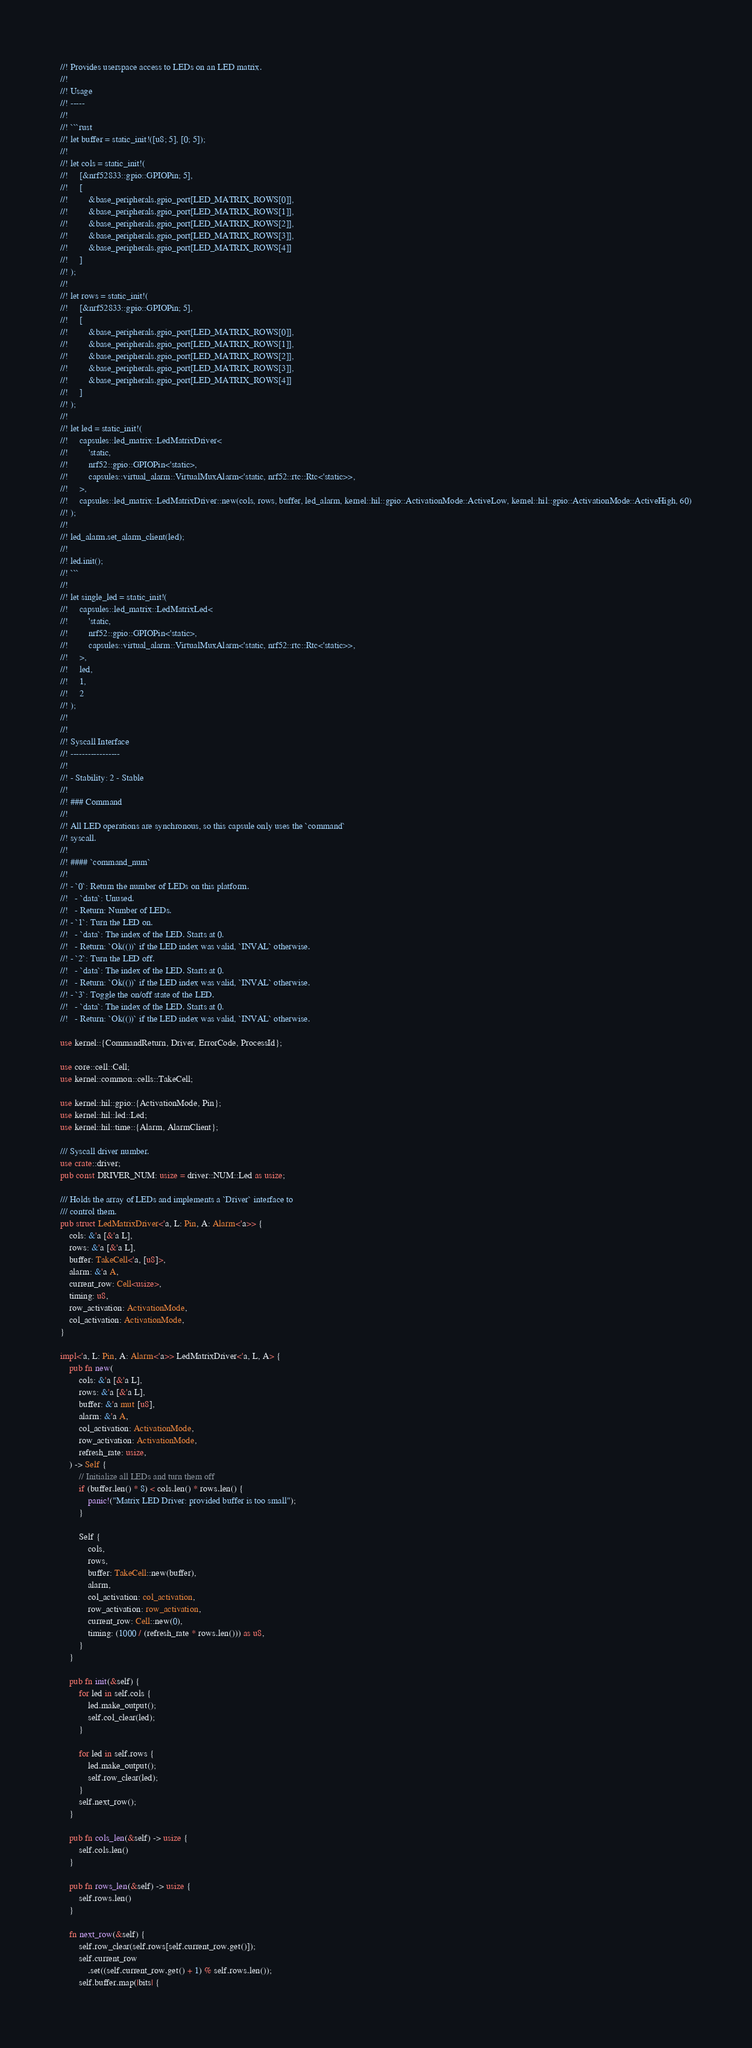<code> <loc_0><loc_0><loc_500><loc_500><_Rust_>//! Provides userspace access to LEDs on an LED matrix.
//!
//! Usage
//! -----
//!
//! ```rust
//! let buffer = static_init!([u8; 5], [0; 5]);
//!
//! let cols = static_init!(
//!     [&nrf52833::gpio::GPIOPin; 5],
//!     [
//!         &base_peripherals.gpio_port[LED_MATRIX_ROWS[0]],
//!         &base_peripherals.gpio_port[LED_MATRIX_ROWS[1]],
//!         &base_peripherals.gpio_port[LED_MATRIX_ROWS[2]],
//!         &base_peripherals.gpio_port[LED_MATRIX_ROWS[3]],
//!         &base_peripherals.gpio_port[LED_MATRIX_ROWS[4]]
//!     ]
//! );
//!
//! let rows = static_init!(
//!     [&nrf52833::gpio::GPIOPin; 5],
//!     [
//!         &base_peripherals.gpio_port[LED_MATRIX_ROWS[0]],
//!         &base_peripherals.gpio_port[LED_MATRIX_ROWS[1]],
//!         &base_peripherals.gpio_port[LED_MATRIX_ROWS[2]],
//!         &base_peripherals.gpio_port[LED_MATRIX_ROWS[3]],
//!         &base_peripherals.gpio_port[LED_MATRIX_ROWS[4]]
//!     ]
//! );
//!
//! let led = static_init!(
//!     capsules::led_matrix::LedMatrixDriver<
//!         'static,
//!         nrf52::gpio::GPIOPin<'static>,
//!         capsules::virtual_alarm::VirtualMuxAlarm<'static, nrf52::rtc::Rtc<'static>>,
//!     >,
//!     capsules::led_matrix::LedMatrixDriver::new(cols, rows, buffer, led_alarm, kernel::hil::gpio::ActivationMode::ActiveLow, kernel::hil::gpio::ActivationMode::ActiveHigh, 60)
//! );
//!
//! led_alarm.set_alarm_client(led);
//!
//! led.init();
//! ```
//!
//! let single_led = static_init!(
//!     capsules::led_matrix::LedMatrixLed<
//!         'static,
//!         nrf52::gpio::GPIOPin<'static>,
//!         capsules::virtual_alarm::VirtualMuxAlarm<'static, nrf52::rtc::Rtc<'static>>,
//!     >,
//!     led,
//!     1,
//!     2
//! );
//!
//!
//! Syscall Interface
//! -----------------
//!
//! - Stability: 2 - Stable
//!
//! ### Command
//!
//! All LED operations are synchronous, so this capsule only uses the `command`
//! syscall.
//!
//! #### `command_num`
//!
//! - `0`: Return the number of LEDs on this platform.
//!   - `data`: Unused.
//!   - Return: Number of LEDs.
//! - `1`: Turn the LED on.
//!   - `data`: The index of the LED. Starts at 0.
//!   - Return: `Ok(())` if the LED index was valid, `INVAL` otherwise.
//! - `2`: Turn the LED off.
//!   - `data`: The index of the LED. Starts at 0.
//!   - Return: `Ok(())` if the LED index was valid, `INVAL` otherwise.
//! - `3`: Toggle the on/off state of the LED.
//!   - `data`: The index of the LED. Starts at 0.
//!   - Return: `Ok(())` if the LED index was valid, `INVAL` otherwise.

use kernel::{CommandReturn, Driver, ErrorCode, ProcessId};

use core::cell::Cell;
use kernel::common::cells::TakeCell;

use kernel::hil::gpio::{ActivationMode, Pin};
use kernel::hil::led::Led;
use kernel::hil::time::{Alarm, AlarmClient};

/// Syscall driver number.
use crate::driver;
pub const DRIVER_NUM: usize = driver::NUM::Led as usize;

/// Holds the array of LEDs and implements a `Driver` interface to
/// control them.
pub struct LedMatrixDriver<'a, L: Pin, A: Alarm<'a>> {
    cols: &'a [&'a L],
    rows: &'a [&'a L],
    buffer: TakeCell<'a, [u8]>,
    alarm: &'a A,
    current_row: Cell<usize>,
    timing: u8,
    row_activation: ActivationMode,
    col_activation: ActivationMode,
}

impl<'a, L: Pin, A: Alarm<'a>> LedMatrixDriver<'a, L, A> {
    pub fn new(
        cols: &'a [&'a L],
        rows: &'a [&'a L],
        buffer: &'a mut [u8],
        alarm: &'a A,
        col_activation: ActivationMode,
        row_activation: ActivationMode,
        refresh_rate: usize,
    ) -> Self {
        // Initialize all LEDs and turn them off
        if (buffer.len() * 8) < cols.len() * rows.len() {
            panic!("Matrix LED Driver: provided buffer is too small");
        }

        Self {
            cols,
            rows,
            buffer: TakeCell::new(buffer),
            alarm,
            col_activation: col_activation,
            row_activation: row_activation,
            current_row: Cell::new(0),
            timing: (1000 / (refresh_rate * rows.len())) as u8,
        }
    }

    pub fn init(&self) {
        for led in self.cols {
            led.make_output();
            self.col_clear(led);
        }

        for led in self.rows {
            led.make_output();
            self.row_clear(led);
        }
        self.next_row();
    }

    pub fn cols_len(&self) -> usize {
        self.cols.len()
    }

    pub fn rows_len(&self) -> usize {
        self.rows.len()
    }

    fn next_row(&self) {
        self.row_clear(self.rows[self.current_row.get()]);
        self.current_row
            .set((self.current_row.get() + 1) % self.rows.len());
        self.buffer.map(|bits| {</code> 